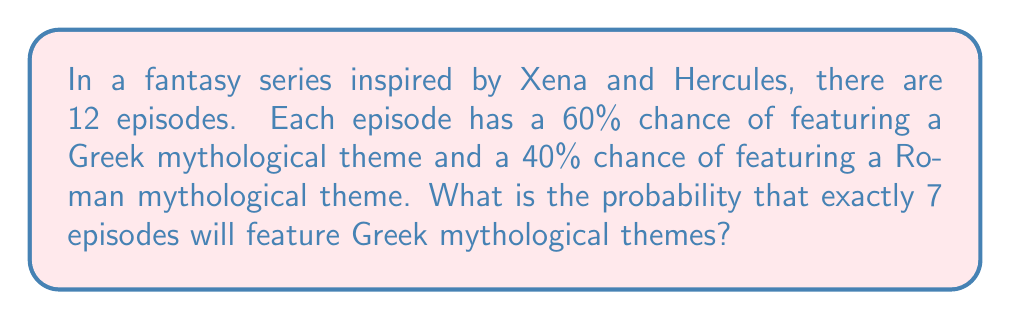Provide a solution to this math problem. To solve this problem, we need to use the binomial probability formula, as we're dealing with a fixed number of independent trials (episodes) with two possible outcomes (Greek or Roman theme).

1. Let's define our variables:
   $n = 12$ (total number of episodes)
   $k = 7$ (number of episodes we want to feature Greek themes)
   $p = 0.60$ (probability of a Greek theme in each episode)
   $q = 1 - p = 0.40$ (probability of a Roman theme in each episode)

2. The binomial probability formula is:

   $P(X = k) = \binom{n}{k} p^k q^{n-k}$

3. We need to calculate the binomial coefficient $\binom{n}{k}$:

   $\binom{12}{7} = \frac{12!}{7!(12-7)!} = \frac{12!}{7!5!} = 792$

4. Now, let's plug everything into the formula:

   $P(X = 7) = 792 \cdot (0.60)^7 \cdot (0.40)^{12-7}$
   
   $= 792 \cdot (0.60)^7 \cdot (0.40)^5$

5. Calculate the powers:

   $(0.60)^7 \approx 0.0279936$
   $(0.40)^5 \approx 0.01024$

6. Multiply all the terms:

   $792 \cdot 0.0279936 \cdot 0.01024 \approx 0.2261$

Therefore, the probability of exactly 7 episodes featuring Greek mythological themes is approximately 0.2261 or 22.61%.
Answer: $0.2261$ or $22.61\%$ 